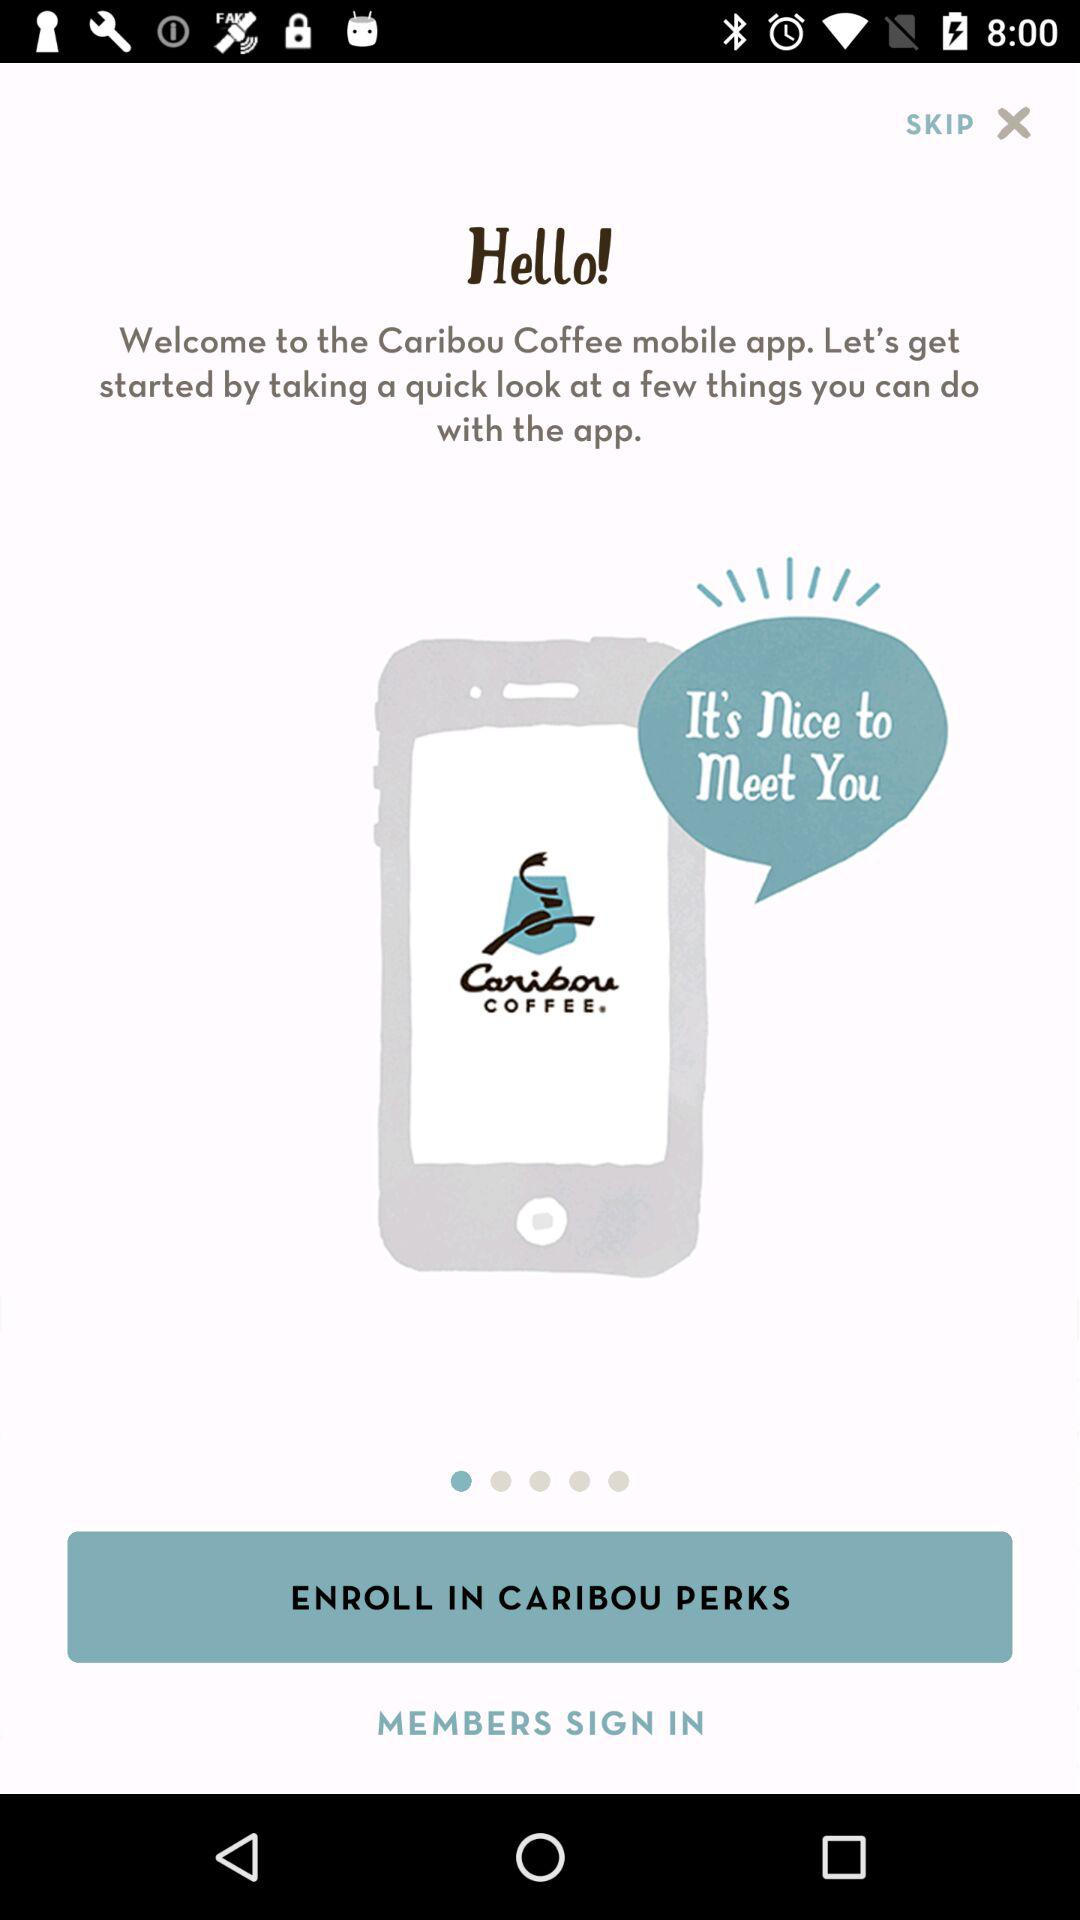What is the name of the application? The name of the application is "Caribou Coffee". 